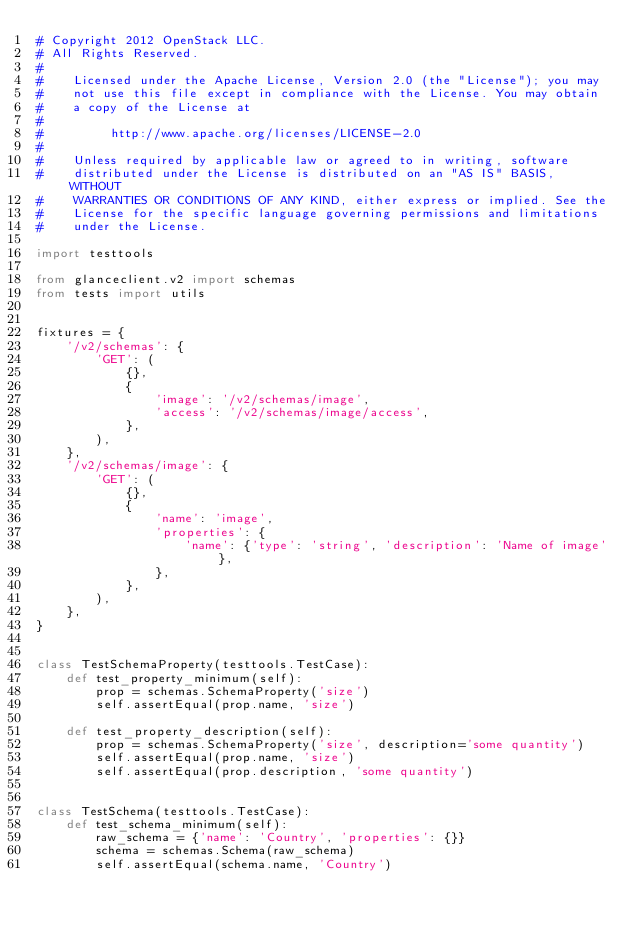<code> <loc_0><loc_0><loc_500><loc_500><_Python_># Copyright 2012 OpenStack LLC.
# All Rights Reserved.
#
#    Licensed under the Apache License, Version 2.0 (the "License"); you may
#    not use this file except in compliance with the License. You may obtain
#    a copy of the License at
#
#         http://www.apache.org/licenses/LICENSE-2.0
#
#    Unless required by applicable law or agreed to in writing, software
#    distributed under the License is distributed on an "AS IS" BASIS, WITHOUT
#    WARRANTIES OR CONDITIONS OF ANY KIND, either express or implied. See the
#    License for the specific language governing permissions and limitations
#    under the License.

import testtools

from glanceclient.v2 import schemas
from tests import utils


fixtures = {
    '/v2/schemas': {
        'GET': (
            {},
            {
                'image': '/v2/schemas/image',
                'access': '/v2/schemas/image/access',
            },
        ),
    },
    '/v2/schemas/image': {
        'GET': (
            {},
            {
                'name': 'image',
                'properties': {
                    'name': {'type': 'string', 'description': 'Name of image'},
                },
            },
        ),
    },
}


class TestSchemaProperty(testtools.TestCase):
    def test_property_minimum(self):
        prop = schemas.SchemaProperty('size')
        self.assertEqual(prop.name, 'size')

    def test_property_description(self):
        prop = schemas.SchemaProperty('size', description='some quantity')
        self.assertEqual(prop.name, 'size')
        self.assertEqual(prop.description, 'some quantity')


class TestSchema(testtools.TestCase):
    def test_schema_minimum(self):
        raw_schema = {'name': 'Country', 'properties': {}}
        schema = schemas.Schema(raw_schema)
        self.assertEqual(schema.name, 'Country')</code> 